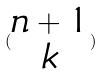Convert formula to latex. <formula><loc_0><loc_0><loc_500><loc_500>( \begin{matrix} n + 1 \\ k \end{matrix} )</formula> 